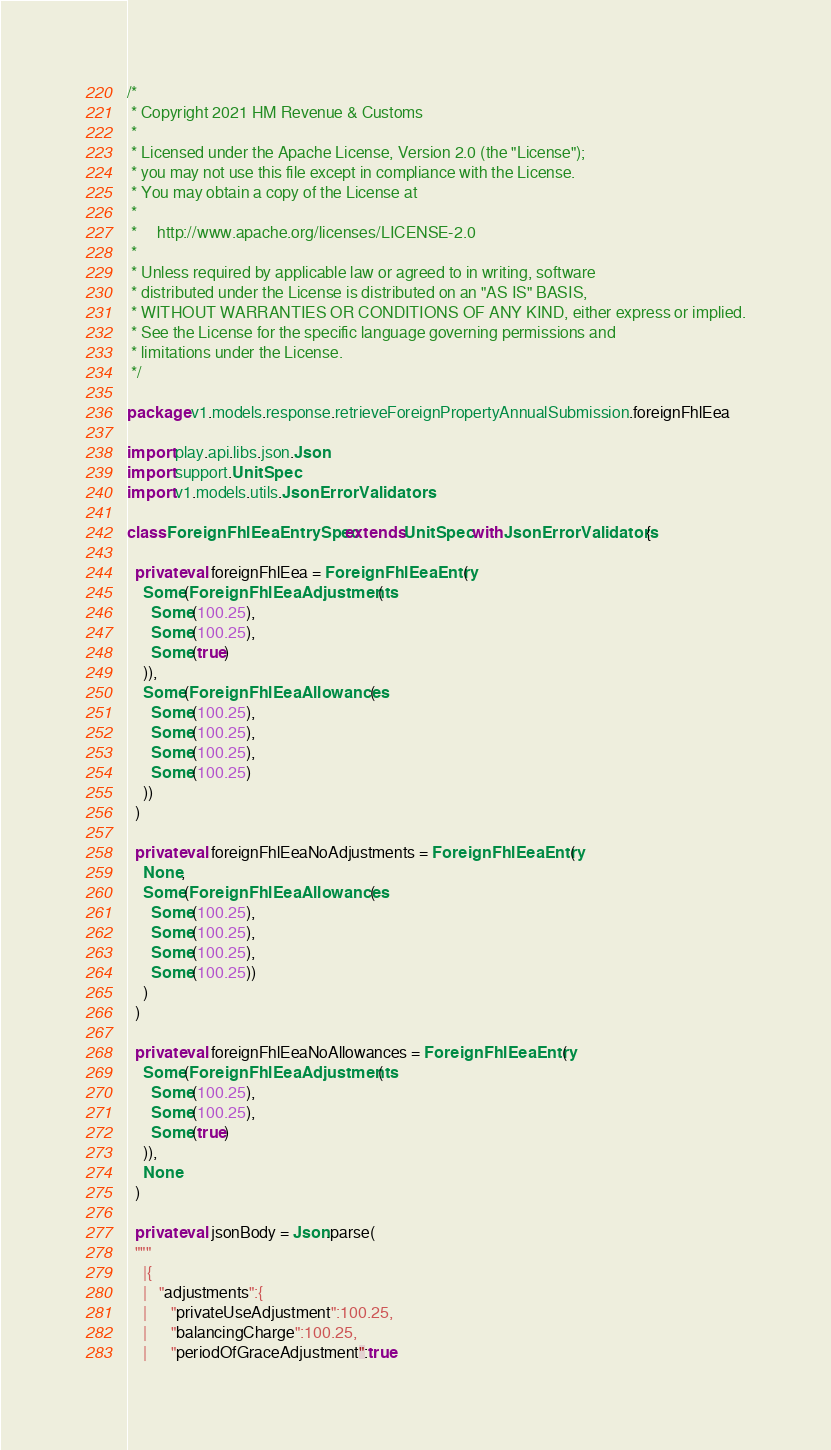<code> <loc_0><loc_0><loc_500><loc_500><_Scala_>/*
 * Copyright 2021 HM Revenue & Customs
 *
 * Licensed under the Apache License, Version 2.0 (the "License");
 * you may not use this file except in compliance with the License.
 * You may obtain a copy of the License at
 *
 *     http://www.apache.org/licenses/LICENSE-2.0
 *
 * Unless required by applicable law or agreed to in writing, software
 * distributed under the License is distributed on an "AS IS" BASIS,
 * WITHOUT WARRANTIES OR CONDITIONS OF ANY KIND, either express or implied.
 * See the License for the specific language governing permissions and
 * limitations under the License.
 */

package v1.models.response.retrieveForeignPropertyAnnualSubmission.foreignFhlEea

import play.api.libs.json.Json
import support.UnitSpec
import v1.models.utils.JsonErrorValidators

class ForeignFhlEeaEntrySpec extends UnitSpec with JsonErrorValidators {

  private val foreignFhlEea = ForeignFhlEeaEntry(
    Some(ForeignFhlEeaAdjustments(
      Some(100.25),
      Some(100.25),
      Some(true)
    )),
    Some(ForeignFhlEeaAllowances(
      Some(100.25),
      Some(100.25),
      Some(100.25),
      Some(100.25)
    ))
  )

  private val foreignFhlEeaNoAdjustments = ForeignFhlEeaEntry(
    None,
    Some(ForeignFhlEeaAllowances(
      Some(100.25),
      Some(100.25),
      Some(100.25),
      Some(100.25))
    )
  )

  private val foreignFhlEeaNoAllowances = ForeignFhlEeaEntry(
    Some(ForeignFhlEeaAdjustments(
      Some(100.25),
      Some(100.25),
      Some(true)
    )),
    None
  )

  private val jsonBody = Json.parse(
  """
    |{
    |   "adjustments":{
    |      "privateUseAdjustment":100.25,
    |      "balancingCharge":100.25,
    |      "periodOfGraceAdjustment":true</code> 